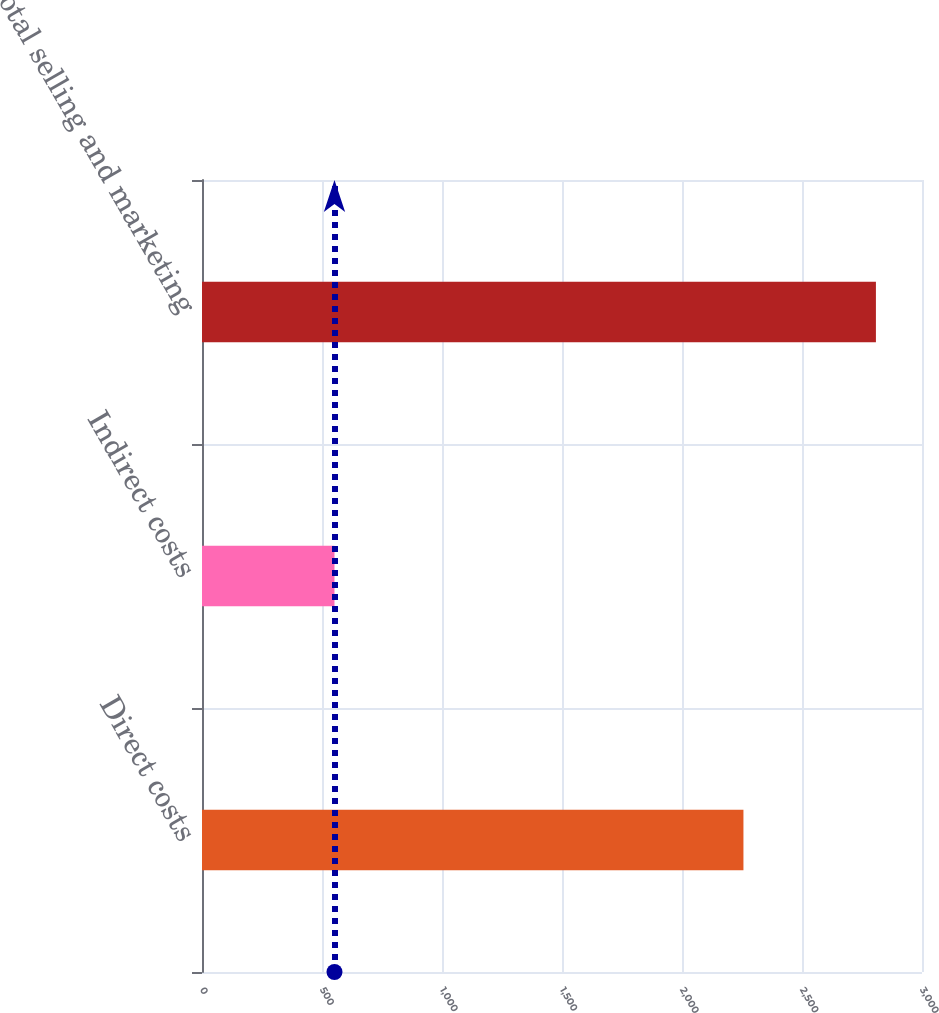<chart> <loc_0><loc_0><loc_500><loc_500><bar_chart><fcel>Direct costs<fcel>Indirect costs<fcel>Total selling and marketing<nl><fcel>2256<fcel>552<fcel>2808<nl></chart> 